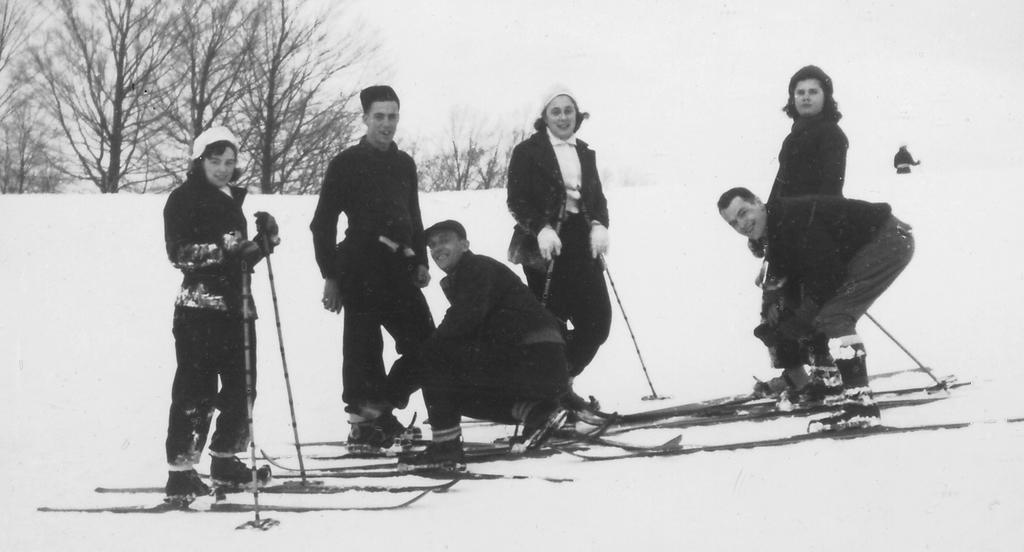In one or two sentences, can you explain what this image depicts? This picture consists of there are six people, some of them holding sticks, at the top there are some trees, there is a person visible on the right side. 